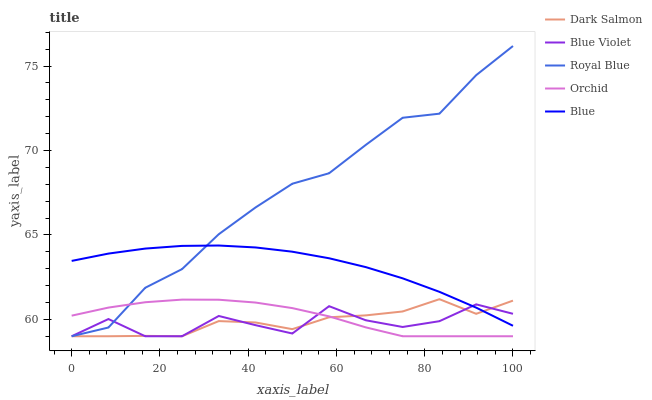Does Blue Violet have the minimum area under the curve?
Answer yes or no. Yes. Does Royal Blue have the maximum area under the curve?
Answer yes or no. Yes. Does Dark Salmon have the minimum area under the curve?
Answer yes or no. No. Does Dark Salmon have the maximum area under the curve?
Answer yes or no. No. Is Blue the smoothest?
Answer yes or no. Yes. Is Blue Violet the roughest?
Answer yes or no. Yes. Is Royal Blue the smoothest?
Answer yes or no. No. Is Royal Blue the roughest?
Answer yes or no. No. Does Royal Blue have the lowest value?
Answer yes or no. Yes. Does Royal Blue have the highest value?
Answer yes or no. Yes. Does Dark Salmon have the highest value?
Answer yes or no. No. Is Orchid less than Blue?
Answer yes or no. Yes. Is Blue greater than Orchid?
Answer yes or no. Yes. Does Orchid intersect Royal Blue?
Answer yes or no. Yes. Is Orchid less than Royal Blue?
Answer yes or no. No. Is Orchid greater than Royal Blue?
Answer yes or no. No. Does Orchid intersect Blue?
Answer yes or no. No. 